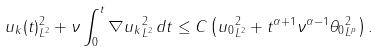<formula> <loc_0><loc_0><loc_500><loc_500>\| u _ { k } ( t ) \| ^ { 2 } _ { L ^ { 2 } } + \nu \int _ { 0 } ^ { t } \| \nabla u _ { k } \| ^ { 2 } _ { L ^ { 2 } } \, d t \leq C \left ( \| u _ { 0 } \| ^ { 2 } _ { L ^ { 2 } } + t ^ { \alpha + 1 } \nu ^ { \alpha - 1 } \| \theta _ { 0 } \| _ { L ^ { p } } ^ { 2 } \right ) .</formula> 